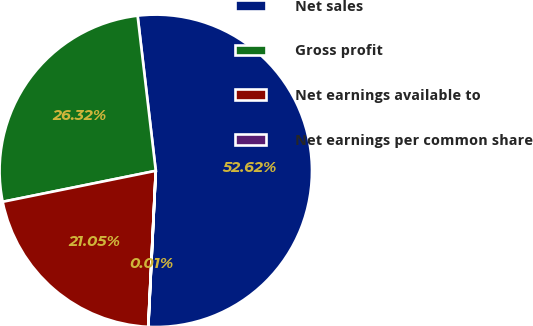<chart> <loc_0><loc_0><loc_500><loc_500><pie_chart><fcel>Net sales<fcel>Gross profit<fcel>Net earnings available to<fcel>Net earnings per common share<nl><fcel>52.62%<fcel>26.32%<fcel>21.05%<fcel>0.01%<nl></chart> 